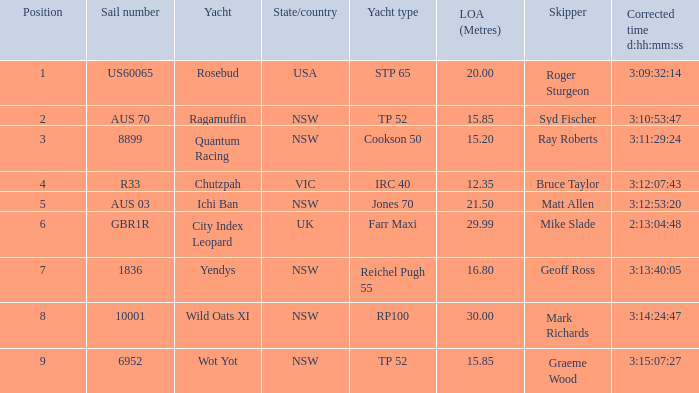Who were all of the skippers with a corrected time of 3:15:07:27? Graeme Wood. 